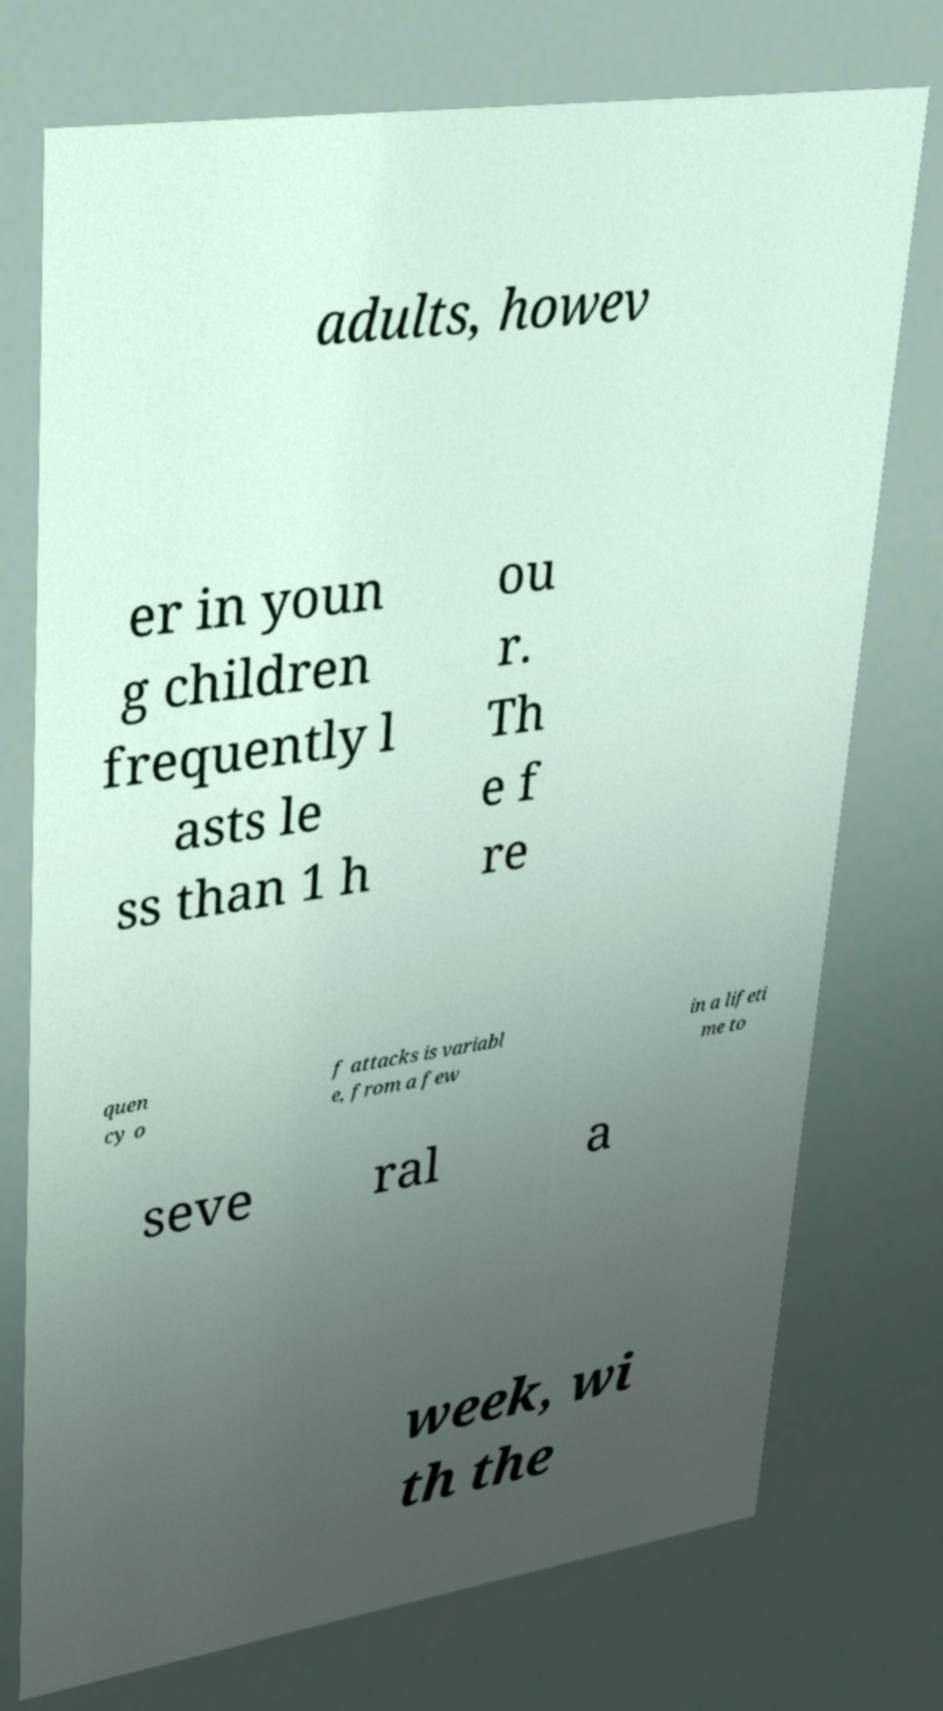Can you accurately transcribe the text from the provided image for me? adults, howev er in youn g children frequently l asts le ss than 1 h ou r. Th e f re quen cy o f attacks is variabl e, from a few in a lifeti me to seve ral a week, wi th the 